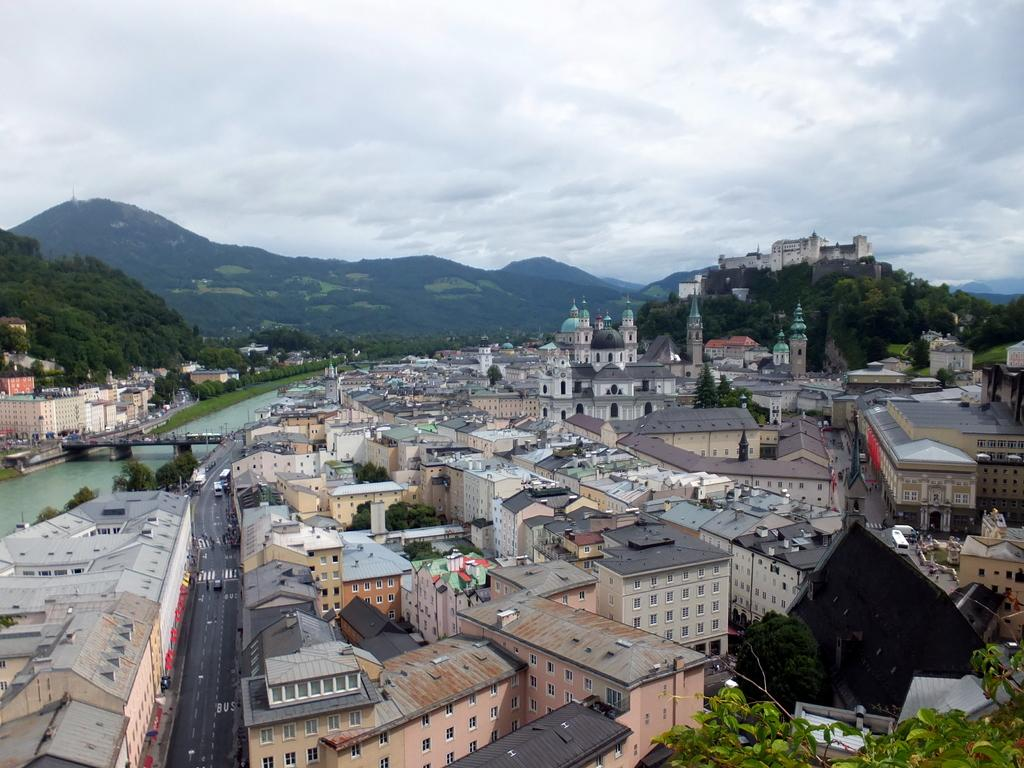What type of structures can be seen in the image? There are houses and buildings in the image. What natural elements are present in the image? There are trees and water visible in the image. What man-made structures are present in the image? There is a bridge and roads in the image. What vehicles can be seen in the image? There are vehicles in the image. What is visible in the background of the image? The background of the image includes hills, trees, and a cloudy sky. What is the governor's opinion on the expansion of the bridge in the image? There is no information about the governor or their opinion in the image. The image only shows a bridge, roads, houses, buildings, trees, water, and a cloudy sky. 